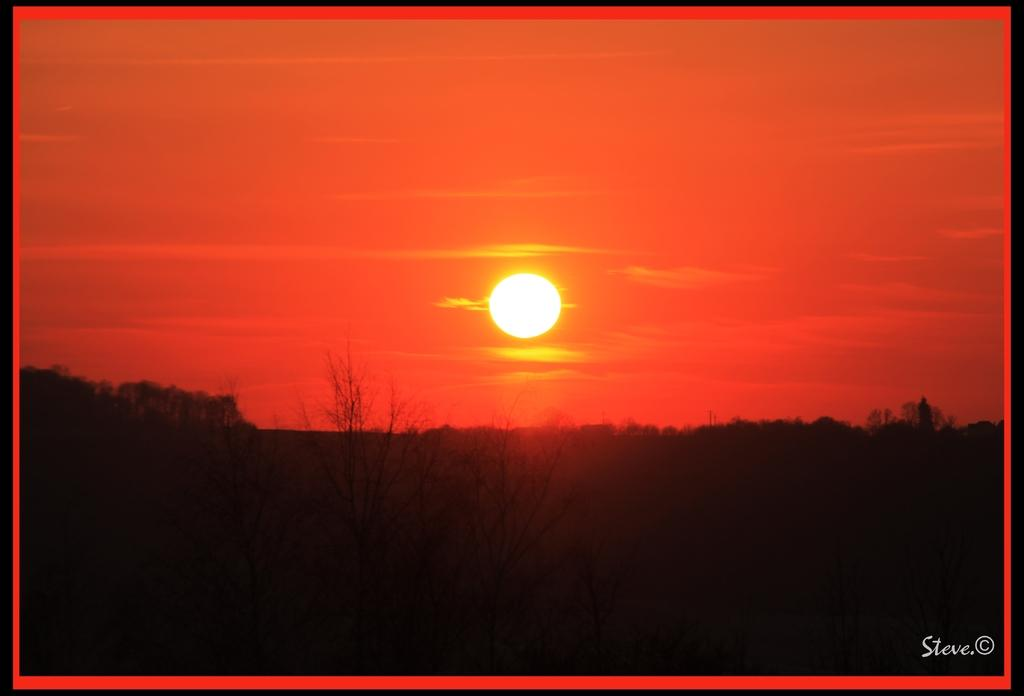What type of natural elements can be seen in the image? There are trees in the image. What can be seen in the background of the image? The background of the image includes the sun and sky. Is there any additional information or marking on the image? Yes, there is a watermark on the image. What verse can be heard being recited by the trees in the image? There is no verse being recited by the trees in the image, as trees do not have the ability to speak or recite verses. 